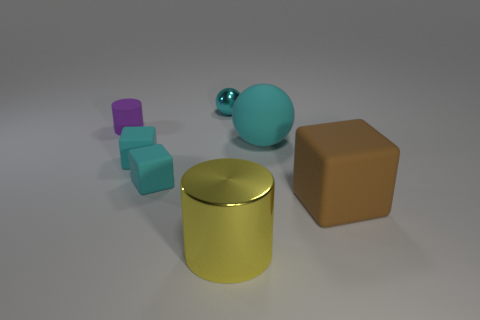Subtract all small blocks. How many blocks are left? 1 Subtract all red balls. How many cyan blocks are left? 2 Subtract 1 cubes. How many cubes are left? 2 Subtract all brown blocks. How many blocks are left? 2 Subtract all red blocks. Subtract all red cylinders. How many blocks are left? 3 Subtract all cubes. How many objects are left? 4 Add 2 tiny cylinders. How many objects exist? 9 Add 5 tiny spheres. How many tiny spheres are left? 6 Add 3 small purple things. How many small purple things exist? 4 Subtract 0 blue cylinders. How many objects are left? 7 